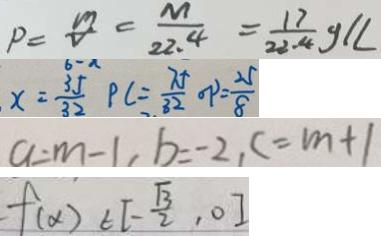Convert formula to latex. <formula><loc_0><loc_0><loc_500><loc_500>P = \frac { m } { V } = \frac { M } { 2 2 . 4 } = \frac { 1 7 } { 2 2 . 4 } g / L 
 x = \frac { 3 5 } { 3 2 } P C = \frac { 7 5 } { 8 2 } o p = \frac { 2 5 } { 8 } 
 a = m - 1 , b = - 2 , c = m + 1 
 f ( \alpha ) \in [ - \frac { \sqrt { 3 } } { 2 } , 0 ]</formula> 